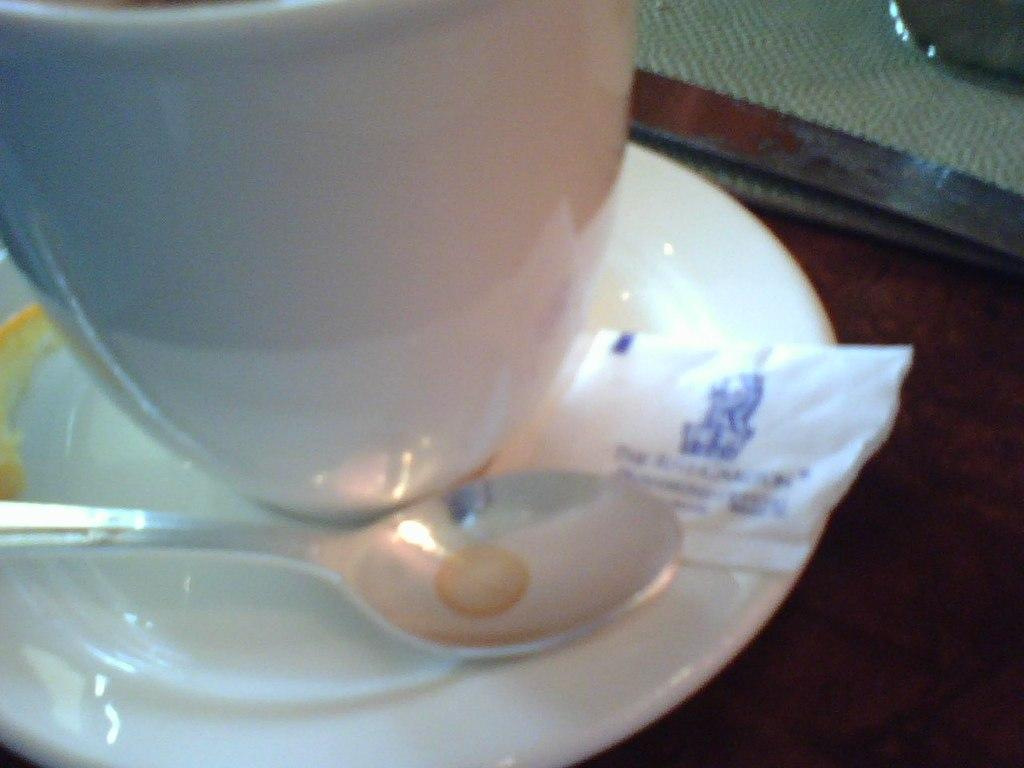What is present on the table in the image? There is a cup and a saucer on the table in the image. What is the cup resting on? The cup is resting on a saucer in the image. What utensil is visible in the image? There is a spoon in the image. What type of cable is wrapped around the cup in the image? There is no cable present in the image; it only features a cup, saucer, and spoon. 